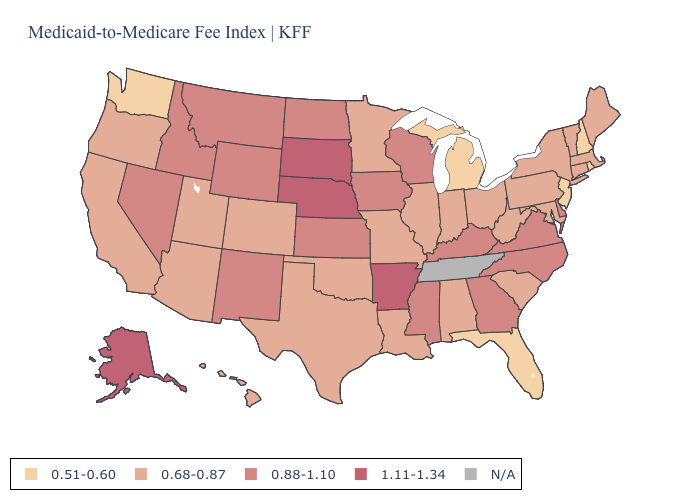Which states have the lowest value in the USA?
Give a very brief answer. Florida, Michigan, New Hampshire, New Jersey, Rhode Island, Washington. Name the states that have a value in the range 0.51-0.60?
Answer briefly. Florida, Michigan, New Hampshire, New Jersey, Rhode Island, Washington. What is the value of Wisconsin?
Answer briefly. 0.88-1.10. What is the value of Louisiana?
Quick response, please. 0.68-0.87. Among the states that border North Carolina , which have the highest value?
Quick response, please. Georgia, Virginia. What is the value of Louisiana?
Quick response, please. 0.68-0.87. What is the lowest value in states that border Vermont?
Quick response, please. 0.51-0.60. How many symbols are there in the legend?
Keep it brief. 5. Name the states that have a value in the range 0.88-1.10?
Answer briefly. Delaware, Georgia, Idaho, Iowa, Kansas, Kentucky, Mississippi, Montana, Nevada, New Mexico, North Carolina, North Dakota, Virginia, Wisconsin, Wyoming. Name the states that have a value in the range 0.68-0.87?
Give a very brief answer. Alabama, Arizona, California, Colorado, Connecticut, Hawaii, Illinois, Indiana, Louisiana, Maine, Maryland, Massachusetts, Minnesota, Missouri, New York, Ohio, Oklahoma, Oregon, Pennsylvania, South Carolina, Texas, Utah, Vermont, West Virginia. What is the value of California?
Keep it brief. 0.68-0.87. What is the highest value in the USA?
Write a very short answer. 1.11-1.34. Which states have the lowest value in the USA?
Answer briefly. Florida, Michigan, New Hampshire, New Jersey, Rhode Island, Washington. 